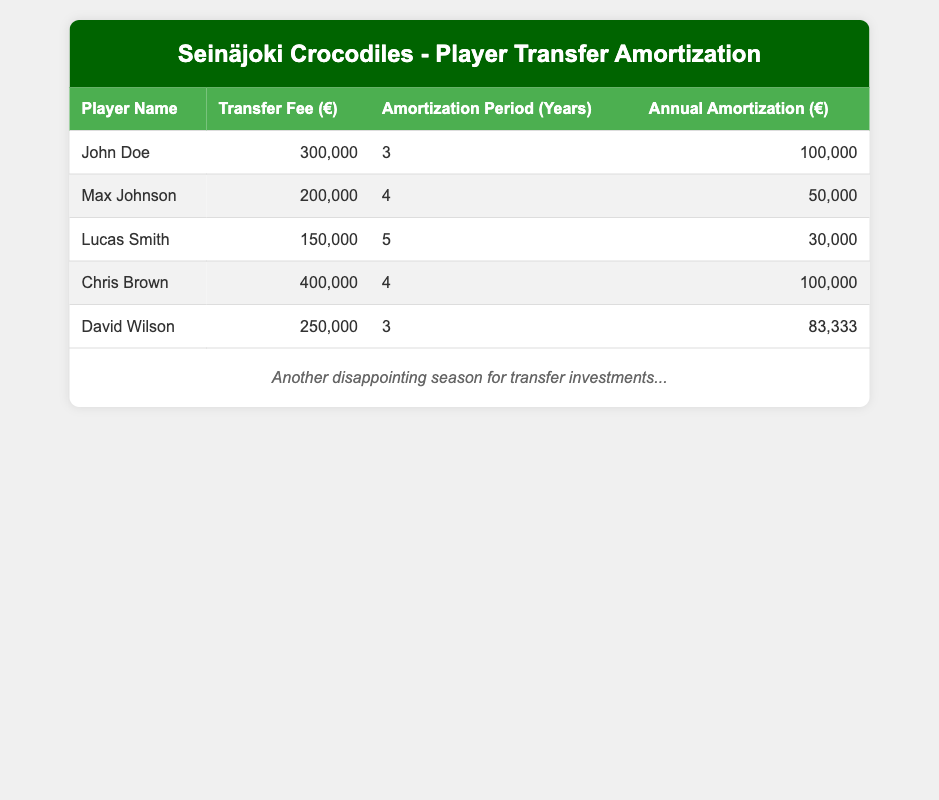What is the transfer fee for Chris Brown? The table lists the transfer fee for each player alongside their names. For Chris Brown, the transfer fee is specified as 400,000 euros.
Answer: 400,000 How long is the amortization period for Lucas Smith? Each player's amortization period is listed in the table. Looking at Lucas Smith's row, the amortization period is stated as 5 years.
Answer: 5 years What is the total annual amortization for all players combined? To find the total annual amortization, we need to sum the annual amortization values from each player's row: 100,000 + 50,000 + 30,000 + 100,000 + 83,333 = 363,333 euros.
Answer: 363,333 Is the amortization period for David Wilson longer than for Max Johnson? David Wilson has an amortization period of 3 years, while Max Johnson has an amortization period of 4 years. Since 3 is not greater than 4, the statement is false.
Answer: No Which player has the highest transfer fee, and what is the fee? By reviewing the transfer fees listed for each player, Chris Brown has the highest fee at 400,000 euros.
Answer: Chris Brown, 400,000 What is the average annual amortization across all players? To calculate the average, add the annual amortization amounts (100,000 + 50,000 + 30,000 + 100,000 + 83,333 = 363,333) and divide by the number of players (5). Thus, the average annual amortization is 363,333 / 5 = 72,666.6 euros.
Answer: 72,666.6 Which player has an annual amortization that is less than 50,000 euros? In the table, looking at the annual amortization amounts, we find that Lucas Smith has an annual amortization of 30,000 euros, which is less than 50,000 euros.
Answer: Lucas Smith If we compare Lucas Smith and Max Johnson, who has a higher transfer fee? Lucas Smith has a transfer fee of 150,000 euros, while Max Johnson's transfer fee is 200,000 euros. Comparatively, 150,000 is less than 200,000, thus Max Johnson has the higher transfer fee.
Answer: Max Johnson Is the total amortization period for all players less than 20 years? Adding the amortization periods gives 3 + 4 + 5 + 4 + 3 = 19 years. Since 19 is indeed less than 20, the statement is true.
Answer: Yes 